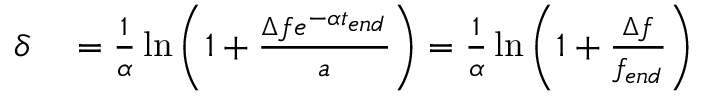<formula> <loc_0><loc_0><loc_500><loc_500>\begin{array} { r l } { \delta } & = \frac { 1 } { \alpha } \ln { \left ( 1 + \frac { \Delta f e ^ { - \alpha t _ { e n d } } } { a } \right ) } = \frac { 1 } { \alpha } \ln { \left ( 1 + \frac { \Delta f } { f _ { e n d } } \right ) } } \end{array}</formula> 